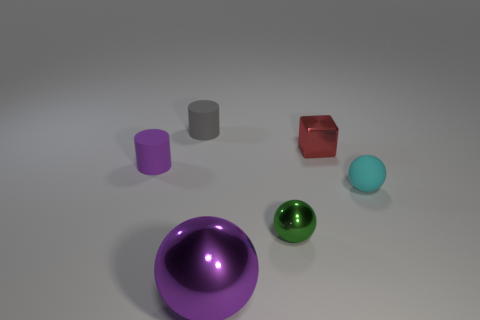Can you tell me more about the lighting in this scene? The lighting in the image seems to be diffused, with soft shadows indicating an overhead light source, possibly meant to highlight the objects without causing harsh reflections. 